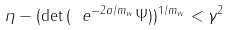<formula> <loc_0><loc_0><loc_500><loc_500>\eta - ( \det { ( \ e ^ { - 2 a / m _ { w } } { \Psi } ) } ) ^ { 1 / m _ { w } } < \gamma ^ { 2 }</formula> 